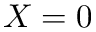<formula> <loc_0><loc_0><loc_500><loc_500>X = 0</formula> 